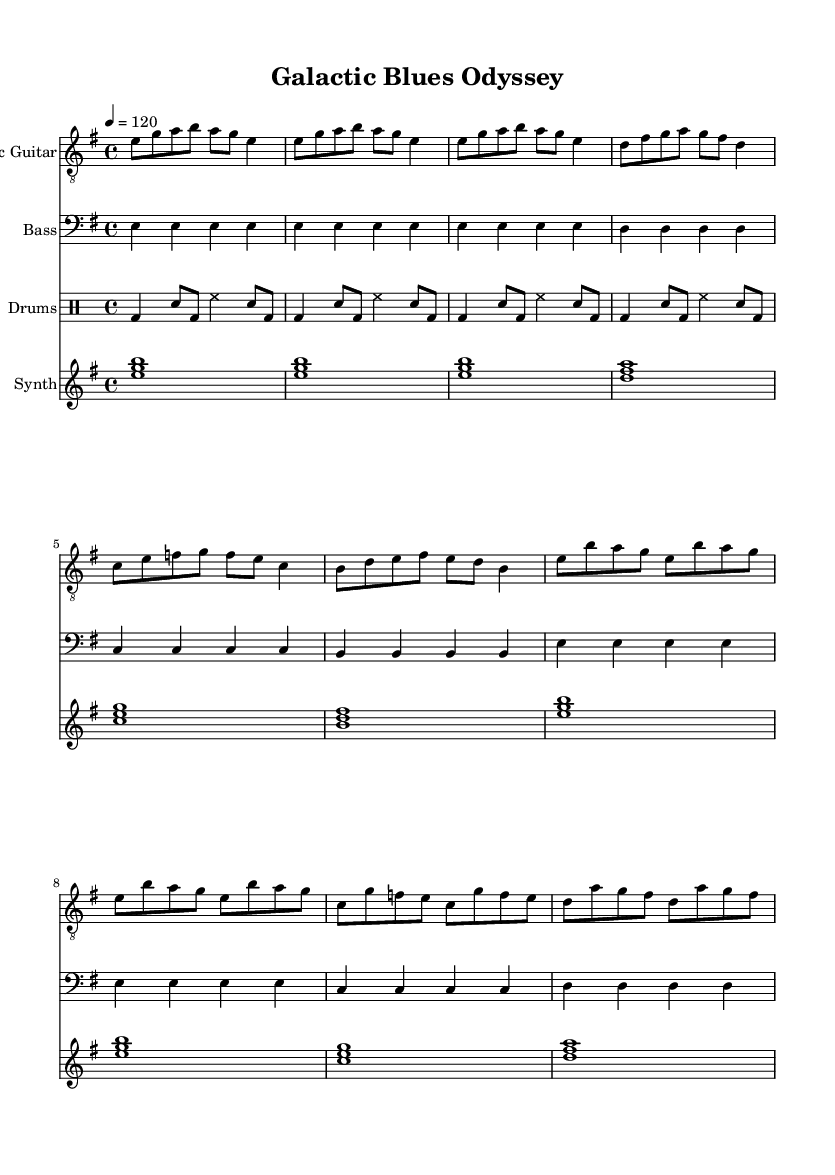What is the key signature of this music? The key signature is E minor, which is indicated by one sharp (F#) and follows the circle of fifths. E minor is the relative minor of G major.
Answer: E minor What is the time signature of this piece? The time signature is 4/4, which means there are four beats per measure and a quarter note gets one beat. This is a common time signature in blues music, allowing for a steady rhythm.
Answer: 4/4 What is the tempo marking for this music? The tempo marking is 120 beats per minute, specified at the beginning of the piece and indicated to produce a medium-fast pace characteristic of electric blues.
Answer: 120 How many measures are in the intro section? The intro section consists of 2 measures, indicated by the repeated musical patterns at the beginning of the electric guitar part.
Answer: 2 What type of pattern does the drums part use? The drums part employs a basic blues shuffle pattern, characterized by the alternating bass drum and snare drum beats, creating a swinging rhythm typical in blues genres.
Answer: Shuffle What is the primary theme evident in the synthesizer part? The synthesizer part features an atmospheric pad playing full chords, contributing to the sci-fi thematic fusion by providing an ethereal and ambient backdrop.
Answer: Atmospheric pad What instrument is labeled as the first part in the score? The first part in the score is labeled "Electric Guitar," which suggests it takes the lead in terms of melody and contributes significantly to the overall sound of the piece.
Answer: Electric Guitar 